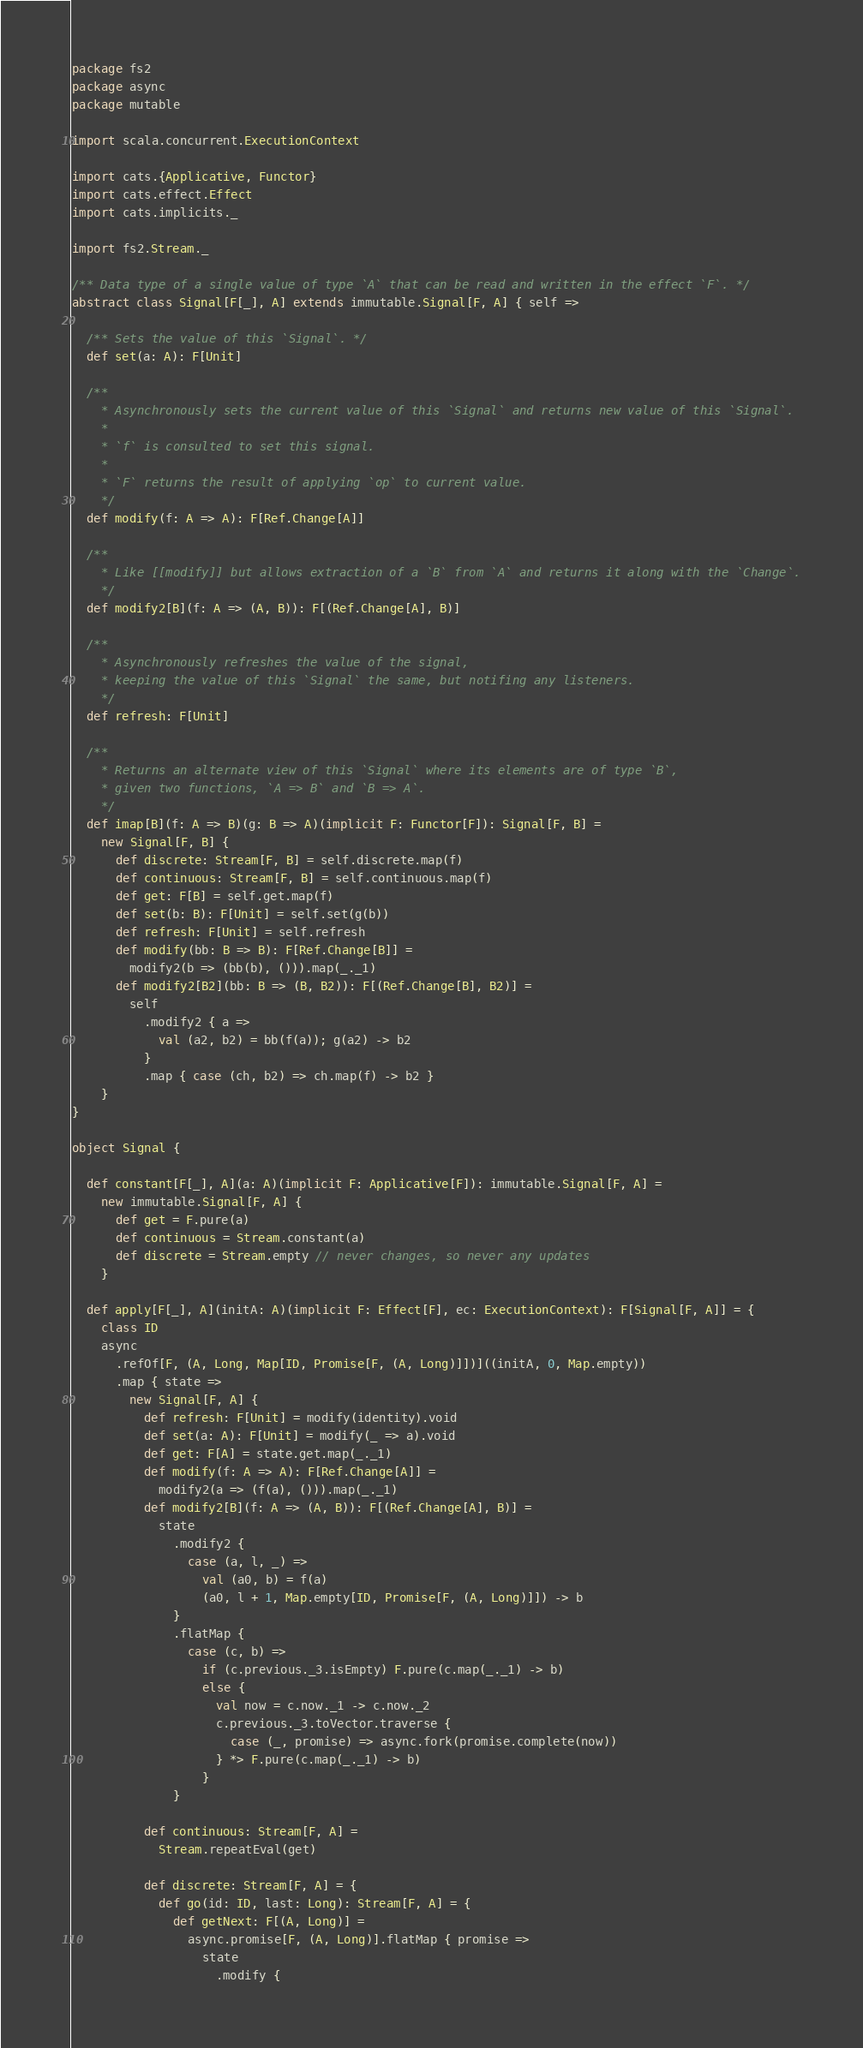<code> <loc_0><loc_0><loc_500><loc_500><_Scala_>package fs2
package async
package mutable

import scala.concurrent.ExecutionContext

import cats.{Applicative, Functor}
import cats.effect.Effect
import cats.implicits._

import fs2.Stream._

/** Data type of a single value of type `A` that can be read and written in the effect `F`. */
abstract class Signal[F[_], A] extends immutable.Signal[F, A] { self =>

  /** Sets the value of this `Signal`. */
  def set(a: A): F[Unit]

  /**
    * Asynchronously sets the current value of this `Signal` and returns new value of this `Signal`.
    *
    * `f` is consulted to set this signal.
    *
    * `F` returns the result of applying `op` to current value.
    */
  def modify(f: A => A): F[Ref.Change[A]]

  /**
    * Like [[modify]] but allows extraction of a `B` from `A` and returns it along with the `Change`.
    */
  def modify2[B](f: A => (A, B)): F[(Ref.Change[A], B)]

  /**
    * Asynchronously refreshes the value of the signal,
    * keeping the value of this `Signal` the same, but notifing any listeners.
    */
  def refresh: F[Unit]

  /**
    * Returns an alternate view of this `Signal` where its elements are of type `B`,
    * given two functions, `A => B` and `B => A`.
    */
  def imap[B](f: A => B)(g: B => A)(implicit F: Functor[F]): Signal[F, B] =
    new Signal[F, B] {
      def discrete: Stream[F, B] = self.discrete.map(f)
      def continuous: Stream[F, B] = self.continuous.map(f)
      def get: F[B] = self.get.map(f)
      def set(b: B): F[Unit] = self.set(g(b))
      def refresh: F[Unit] = self.refresh
      def modify(bb: B => B): F[Ref.Change[B]] =
        modify2(b => (bb(b), ())).map(_._1)
      def modify2[B2](bb: B => (B, B2)): F[(Ref.Change[B], B2)] =
        self
          .modify2 { a =>
            val (a2, b2) = bb(f(a)); g(a2) -> b2
          }
          .map { case (ch, b2) => ch.map(f) -> b2 }
    }
}

object Signal {

  def constant[F[_], A](a: A)(implicit F: Applicative[F]): immutable.Signal[F, A] =
    new immutable.Signal[F, A] {
      def get = F.pure(a)
      def continuous = Stream.constant(a)
      def discrete = Stream.empty // never changes, so never any updates
    }

  def apply[F[_], A](initA: A)(implicit F: Effect[F], ec: ExecutionContext): F[Signal[F, A]] = {
    class ID
    async
      .refOf[F, (A, Long, Map[ID, Promise[F, (A, Long)]])]((initA, 0, Map.empty))
      .map { state =>
        new Signal[F, A] {
          def refresh: F[Unit] = modify(identity).void
          def set(a: A): F[Unit] = modify(_ => a).void
          def get: F[A] = state.get.map(_._1)
          def modify(f: A => A): F[Ref.Change[A]] =
            modify2(a => (f(a), ())).map(_._1)
          def modify2[B](f: A => (A, B)): F[(Ref.Change[A], B)] =
            state
              .modify2 {
                case (a, l, _) =>
                  val (a0, b) = f(a)
                  (a0, l + 1, Map.empty[ID, Promise[F, (A, Long)]]) -> b
              }
              .flatMap {
                case (c, b) =>
                  if (c.previous._3.isEmpty) F.pure(c.map(_._1) -> b)
                  else {
                    val now = c.now._1 -> c.now._2
                    c.previous._3.toVector.traverse {
                      case (_, promise) => async.fork(promise.complete(now))
                    } *> F.pure(c.map(_._1) -> b)
                  }
              }

          def continuous: Stream[F, A] =
            Stream.repeatEval(get)

          def discrete: Stream[F, A] = {
            def go(id: ID, last: Long): Stream[F, A] = {
              def getNext: F[(A, Long)] =
                async.promise[F, (A, Long)].flatMap { promise =>
                  state
                    .modify {</code> 